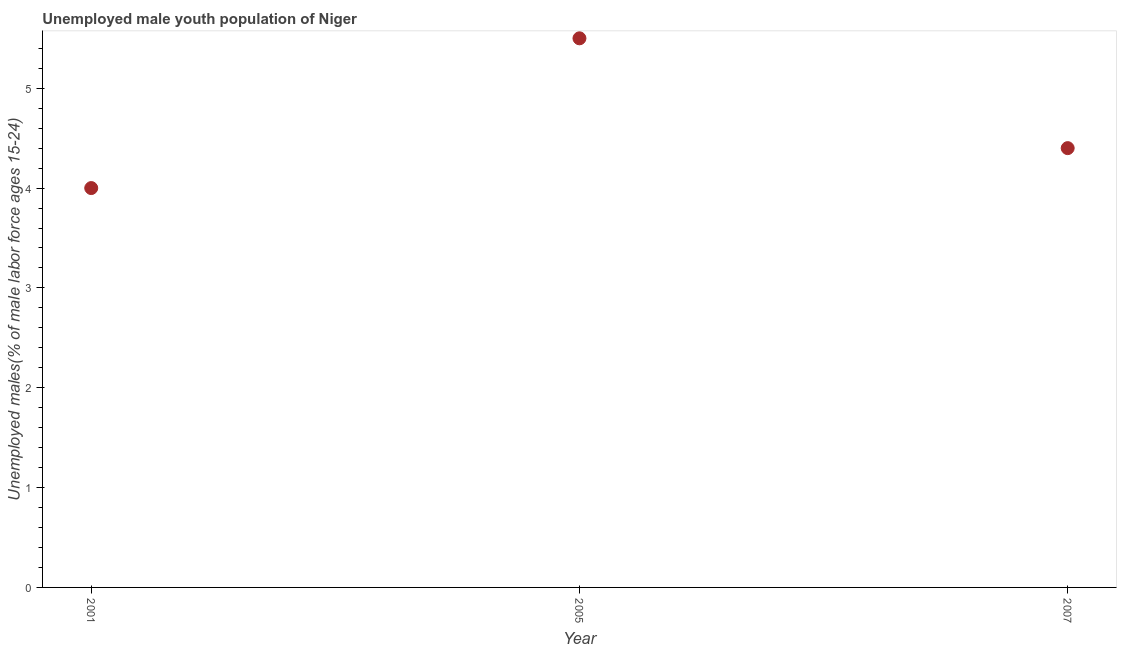What is the unemployed male youth in 2001?
Make the answer very short. 4. Across all years, what is the maximum unemployed male youth?
Offer a very short reply. 5.5. Across all years, what is the minimum unemployed male youth?
Give a very brief answer. 4. In which year was the unemployed male youth maximum?
Provide a short and direct response. 2005. In which year was the unemployed male youth minimum?
Your answer should be compact. 2001. What is the sum of the unemployed male youth?
Offer a terse response. 13.9. What is the difference between the unemployed male youth in 2001 and 2007?
Your answer should be very brief. -0.4. What is the average unemployed male youth per year?
Provide a succinct answer. 4.63. What is the median unemployed male youth?
Provide a short and direct response. 4.4. In how many years, is the unemployed male youth greater than 3.8 %?
Offer a terse response. 3. What is the ratio of the unemployed male youth in 2005 to that in 2007?
Provide a succinct answer. 1.25. Is the difference between the unemployed male youth in 2001 and 2005 greater than the difference between any two years?
Keep it short and to the point. Yes. What is the difference between the highest and the second highest unemployed male youth?
Give a very brief answer. 1.1. What is the difference between the highest and the lowest unemployed male youth?
Your response must be concise. 1.5. In how many years, is the unemployed male youth greater than the average unemployed male youth taken over all years?
Keep it short and to the point. 1. How many dotlines are there?
Offer a very short reply. 1. Does the graph contain any zero values?
Make the answer very short. No. Does the graph contain grids?
Offer a very short reply. No. What is the title of the graph?
Your answer should be very brief. Unemployed male youth population of Niger. What is the label or title of the X-axis?
Provide a short and direct response. Year. What is the label or title of the Y-axis?
Your answer should be compact. Unemployed males(% of male labor force ages 15-24). What is the Unemployed males(% of male labor force ages 15-24) in 2001?
Provide a short and direct response. 4. What is the Unemployed males(% of male labor force ages 15-24) in 2007?
Make the answer very short. 4.4. What is the difference between the Unemployed males(% of male labor force ages 15-24) in 2001 and 2005?
Offer a terse response. -1.5. What is the difference between the Unemployed males(% of male labor force ages 15-24) in 2005 and 2007?
Make the answer very short. 1.1. What is the ratio of the Unemployed males(% of male labor force ages 15-24) in 2001 to that in 2005?
Ensure brevity in your answer.  0.73. What is the ratio of the Unemployed males(% of male labor force ages 15-24) in 2001 to that in 2007?
Offer a very short reply. 0.91. 